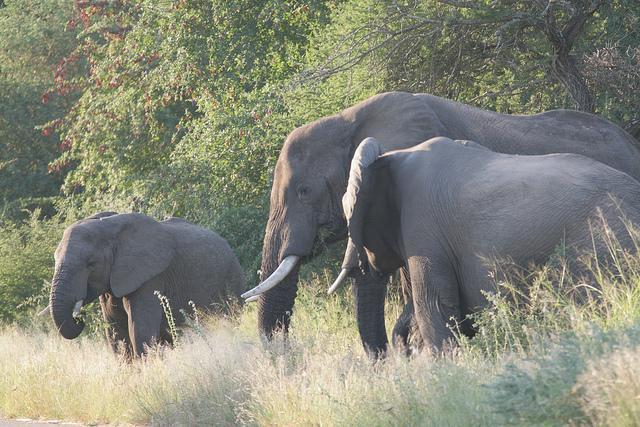How many elephants are in the picture?
Give a very brief answer. 3. How many baby elephants are there?
Give a very brief answer. 1. How many elephants are in this photo?
Give a very brief answer. 3. How many elephants are there?
Give a very brief answer. 3. How many people wears yellow jackets?
Give a very brief answer. 0. 